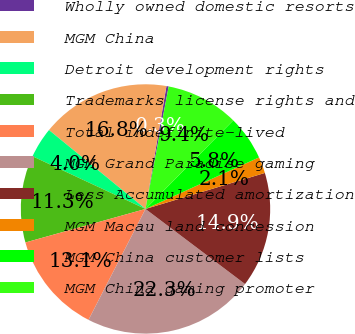Convert chart to OTSL. <chart><loc_0><loc_0><loc_500><loc_500><pie_chart><fcel>Wholly owned domestic resorts<fcel>MGM China<fcel>Detroit development rights<fcel>Trademarks license rights and<fcel>Total indefinite-lived<fcel>MGM Grand Paradise gaming<fcel>Less Accumulated amortization<fcel>MGM Macau land concession<fcel>MGM China customer lists<fcel>MGM China gaming promoter<nl><fcel>0.29%<fcel>16.78%<fcel>3.96%<fcel>11.28%<fcel>13.11%<fcel>22.27%<fcel>14.95%<fcel>2.12%<fcel>5.79%<fcel>9.45%<nl></chart> 